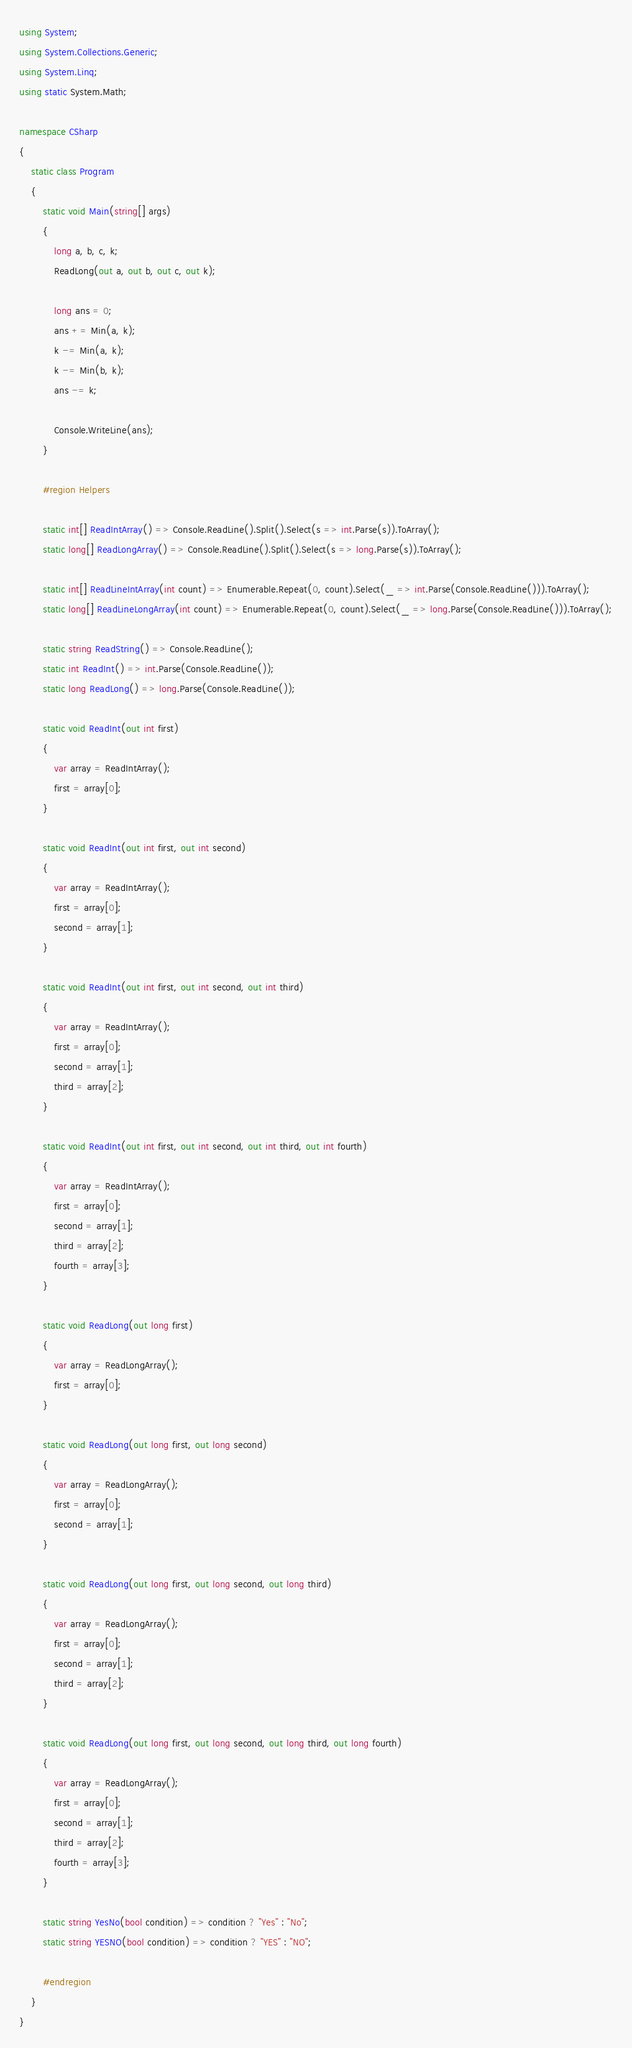<code> <loc_0><loc_0><loc_500><loc_500><_C#_>using System;
using System.Collections.Generic;
using System.Linq;
using static System.Math;

namespace CSharp
{
    static class Program
    {
        static void Main(string[] args)
        {
            long a, b, c, k;
            ReadLong(out a, out b, out c, out k);

            long ans = 0;
            ans += Min(a, k);
            k -= Min(a, k);
            k -= Min(b, k);
            ans -= k;

            Console.WriteLine(ans);
        }

        #region Helpers

        static int[] ReadIntArray() => Console.ReadLine().Split().Select(s => int.Parse(s)).ToArray();
        static long[] ReadLongArray() => Console.ReadLine().Split().Select(s => long.Parse(s)).ToArray();

        static int[] ReadLineIntArray(int count) => Enumerable.Repeat(0, count).Select(_ => int.Parse(Console.ReadLine())).ToArray();
        static long[] ReadLineLongArray(int count) => Enumerable.Repeat(0, count).Select(_ => long.Parse(Console.ReadLine())).ToArray();

        static string ReadString() => Console.ReadLine();
        static int ReadInt() => int.Parse(Console.ReadLine());
        static long ReadLong() => long.Parse(Console.ReadLine());

        static void ReadInt(out int first)
        {
            var array = ReadIntArray();
            first = array[0];
        }

        static void ReadInt(out int first, out int second)
        {
            var array = ReadIntArray();
            first = array[0];
            second = array[1];
        }

        static void ReadInt(out int first, out int second, out int third)
        {
            var array = ReadIntArray();
            first = array[0];
            second = array[1];
            third = array[2];
        }

        static void ReadInt(out int first, out int second, out int third, out int fourth)
        {
            var array = ReadIntArray();
            first = array[0];
            second = array[1];
            third = array[2];
            fourth = array[3];
        }

        static void ReadLong(out long first)
        {
            var array = ReadLongArray();
            first = array[0];
        }

        static void ReadLong(out long first, out long second)
        {
            var array = ReadLongArray();
            first = array[0];
            second = array[1];
        }

        static void ReadLong(out long first, out long second, out long third)
        {
            var array = ReadLongArray();
            first = array[0];
            second = array[1];
            third = array[2];
        }

        static void ReadLong(out long first, out long second, out long third, out long fourth)
        {
            var array = ReadLongArray();
            first = array[0];
            second = array[1];
            third = array[2];
            fourth = array[3];
        }

        static string YesNo(bool condition) => condition ? "Yes" : "No";
        static string YESNO(bool condition) => condition ? "YES" : "NO";

        #endregion
    }
}</code> 